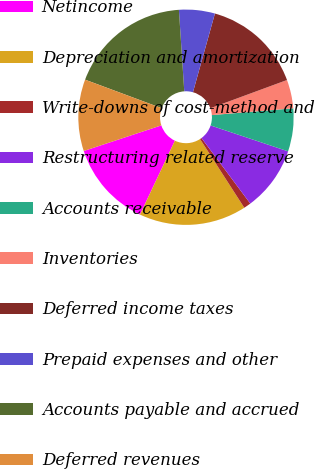<chart> <loc_0><loc_0><loc_500><loc_500><pie_chart><fcel>Netincome<fcel>Depreciation and amortization<fcel>Write-downs of cost-method and<fcel>Restructuring related reserve<fcel>Accounts receivable<fcel>Inventories<fcel>Deferred income taxes<fcel>Prepaid expenses and other<fcel>Accounts payable and accrued<fcel>Deferred revenues<nl><fcel>12.9%<fcel>16.13%<fcel>1.08%<fcel>9.68%<fcel>6.45%<fcel>4.3%<fcel>15.05%<fcel>5.38%<fcel>18.28%<fcel>10.75%<nl></chart> 